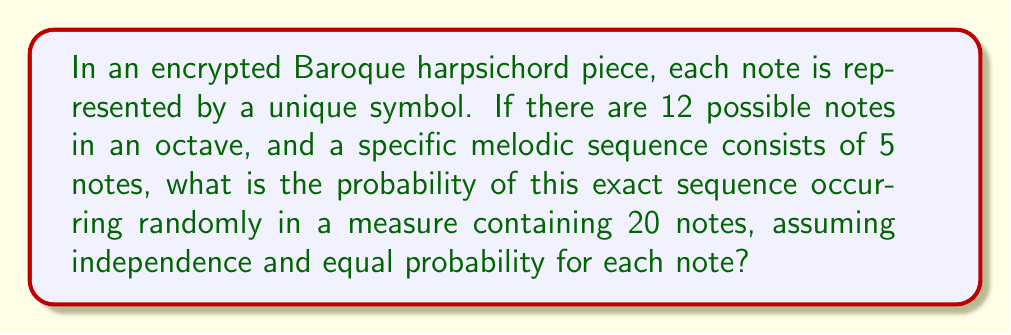Can you solve this math problem? Let's approach this step-by-step:

1) First, we need to calculate the probability of getting the specific 5-note sequence:
   - There are 12 possible notes for each position
   - The probability of getting each correct note is $\frac{1}{12}$
   - For all 5 notes to be correct, we multiply these probabilities:
     $$P(\text{correct sequence}) = (\frac{1}{12})^5 = \frac{1}{12^5}$$

2) Now, we need to consider where this sequence could start within the 20-note measure:
   - The sequence is 5 notes long
   - It could start at any of the first 16 positions (20 - 5 + 1 = 16)

3) We can treat this as 16 independent trials, each with a probability of $\frac{1}{12^5}$

4) The probability of the sequence occurring at least once is the complement of it not occurring at all:
   $$P(\text{at least once}) = 1 - P(\text{never occurring})$$

5) The probability of it not occurring in a single trial is $(1 - \frac{1}{12^5})$

6) For it to not occur in any of the 16 trials:
   $$P(\text{never occurring}) = (1 - \frac{1}{12^5})^{16}$$

7) Therefore, the probability of it occurring at least once is:
   $$P(\text{at least once}) = 1 - (1 - \frac{1}{12^5})^{16}$$

8) Calculating this:
   $$1 - (1 - \frac{1}{248832})^{16} \approx 0.000064276$$
Answer: $1 - (1 - \frac{1}{12^5})^{16} \approx 0.000064276$ 